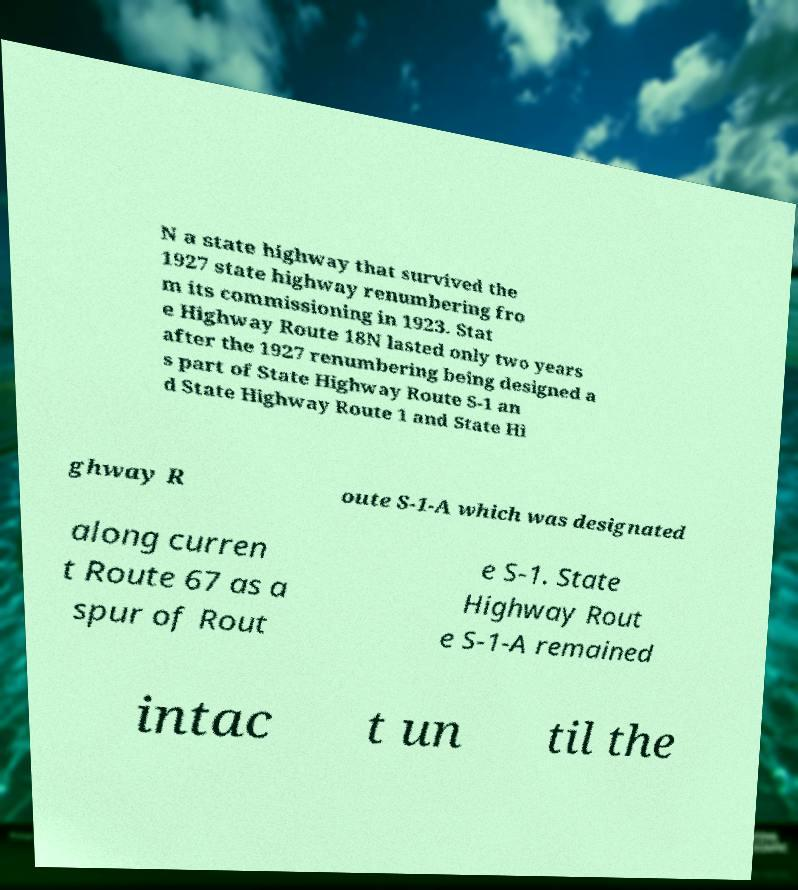Can you accurately transcribe the text from the provided image for me? N a state highway that survived the 1927 state highway renumbering fro m its commissioning in 1923. Stat e Highway Route 18N lasted only two years after the 1927 renumbering being designed a s part of State Highway Route S-1 an d State Highway Route 1 and State Hi ghway R oute S-1-A which was designated along curren t Route 67 as a spur of Rout e S-1. State Highway Rout e S-1-A remained intac t un til the 